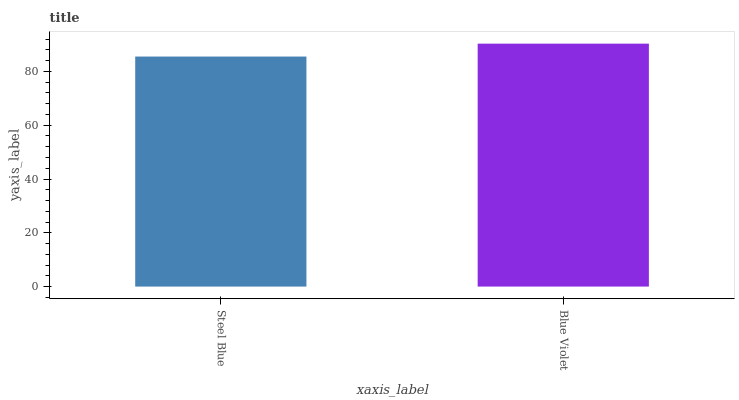Is Blue Violet the minimum?
Answer yes or no. No. Is Blue Violet greater than Steel Blue?
Answer yes or no. Yes. Is Steel Blue less than Blue Violet?
Answer yes or no. Yes. Is Steel Blue greater than Blue Violet?
Answer yes or no. No. Is Blue Violet less than Steel Blue?
Answer yes or no. No. Is Blue Violet the high median?
Answer yes or no. Yes. Is Steel Blue the low median?
Answer yes or no. Yes. Is Steel Blue the high median?
Answer yes or no. No. Is Blue Violet the low median?
Answer yes or no. No. 